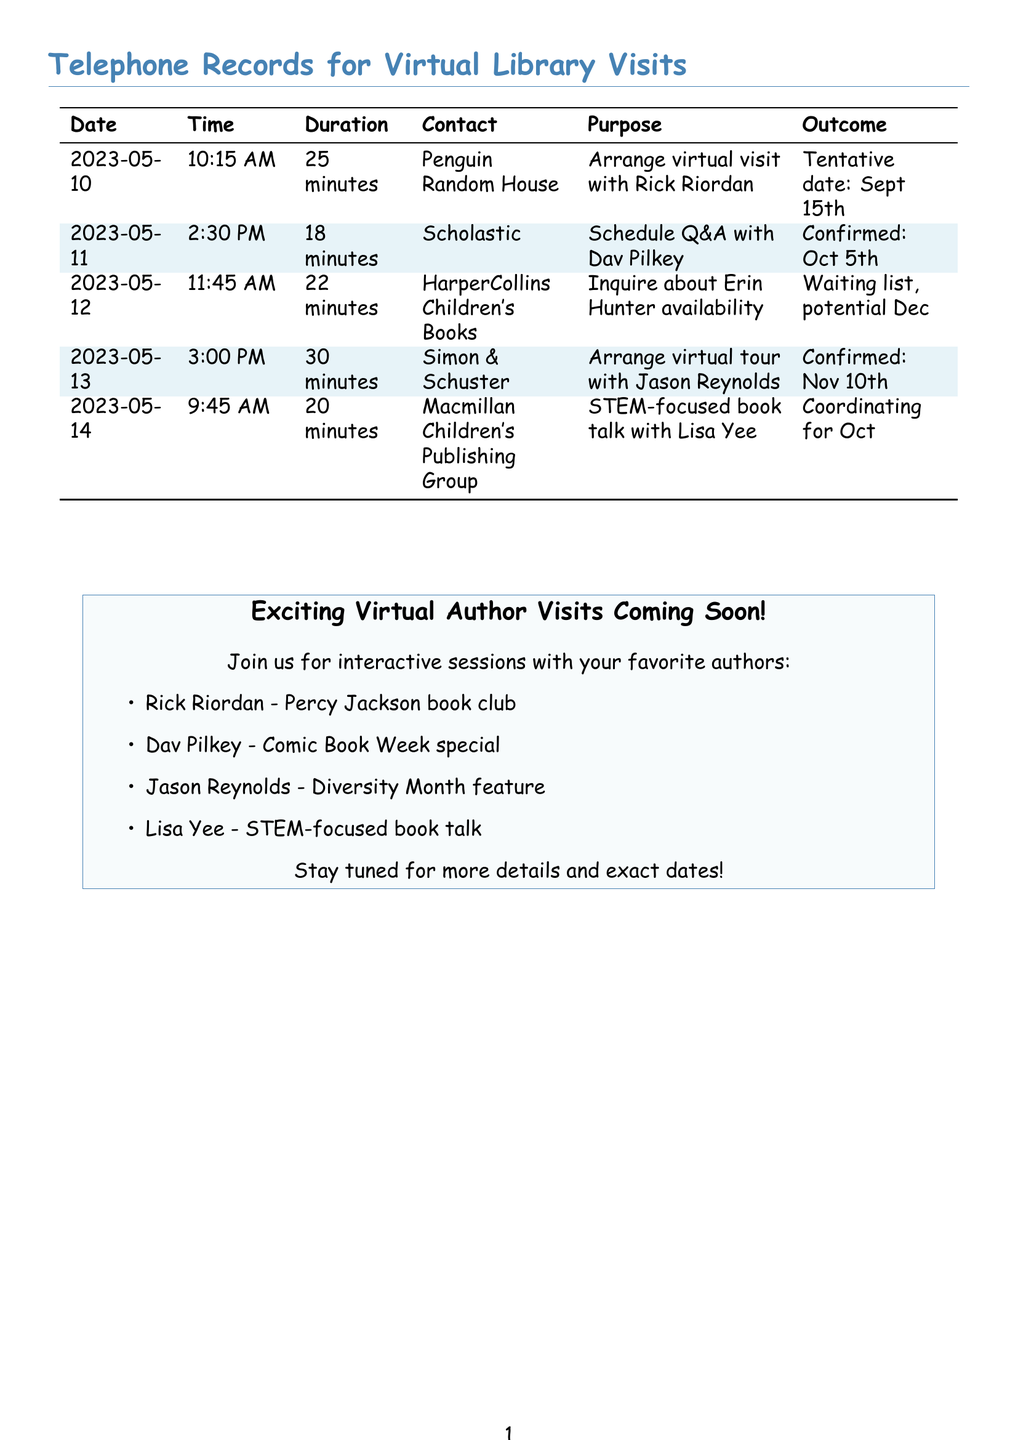what is the date of the virtual visit with Rick Riordan? The date mentioned for the tentative virtual visit with Rick Riordan is September 15th, 2023.
Answer: September 15th who is confirmed for the Q&A session on October 5th? The document states that Dav Pilkey is confirmed for the Q&A session on October 5th.
Answer: Dav Pilkey how long was the call with Scholastic? The duration of the call with Scholastic is indicated as 18 minutes.
Answer: 18 minutes which publisher is coordinating a talk with Lisa Yee? The publisher coordinating the talk with Lisa Yee is Macmillan Children's Publishing Group.
Answer: Macmillan Children's Publishing Group what is the purpose of the call made on May 12th? The purpose of the call made on May 12th is to inquire about Erin Hunter's availability.
Answer: Inquire about Erin Hunter availability how many authors have confirmed their visits according to the records? There are three confirmed authors for their visits as per the records provided.
Answer: Three what is the duration of the call with Simon & Schuster? The duration of the call with Simon & Schuster is noted as 30 minutes.
Answer: 30 minutes what interactive session is planned with Jason Reynolds? The interactive session planned with Jason Reynolds is for Diversity Month feature.
Answer: Diversity Month feature who has a waiting list for their virtual visit? The document states that Erin Hunter has a waiting list for her virtual visit.
Answer: Erin Hunter 